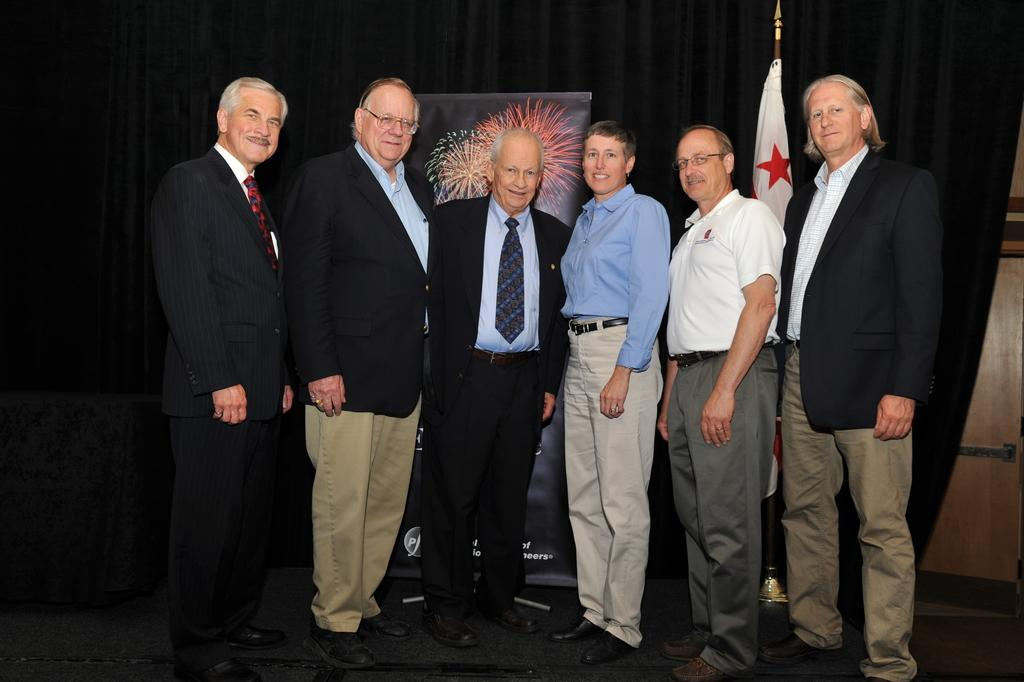What is the gender of the person in the image? There is a woman in the image. How many men are present in the image? There are five men in the image. Where are the people standing in the image? The people are standing on the floor. What is the facial expression of the people in the image? The people are smiling. What can be seen in the background of the image? There is a banner, a flag, and curtains in the background of the image. What type of wound can be seen on the woman's arm in the image? There is no wound visible on the woman's arm in the image. What type of juice is being served in the image? There is no juice present in the image. 